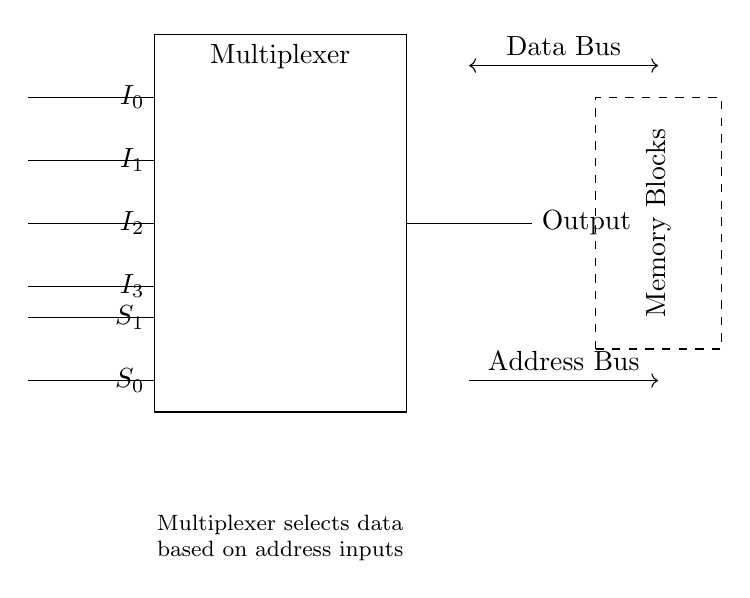What is the function of the multiplexer in this circuit? The multiplexer selects one of the multiple input signals based on the selection lines provided. It routes the chosen input to the output.
Answer: Selecting input signals What are the input signals to the multiplexer? The input signals labeled are I zero, I one, I two, and I three. Each represents a distinct data line to the multiplexer.
Answer: I zero, I one, I two, I three How many selection lines are present in this circuit? There are two selection lines labeled S zero and S one, which control which input is passed to the output.
Answer: Two What is the output of the multiplexer connected to? The output of the multiplexer is connected to the memory blocks, which receive the selected input data for processing.
Answer: Memory blocks Which bus connects the output to the memory blocks? The output is connected via the data bus, which transfers the selected data between the multiplexer and the memory blocks.
Answer: Data bus What is indicated by the dashed rectangle in the circuit? The dashed rectangle represents the memory blocks, indicating the components that the multiplexer interfaces with to transfer data.
Answer: Memory blocks If the select lines are set to zero, which input would be routed to the output? If both select lines S zero and S one are set to zero, the multiplexer will route input I zero to the output, as it corresponds to the selection of both lines being low.
Answer: I zero 